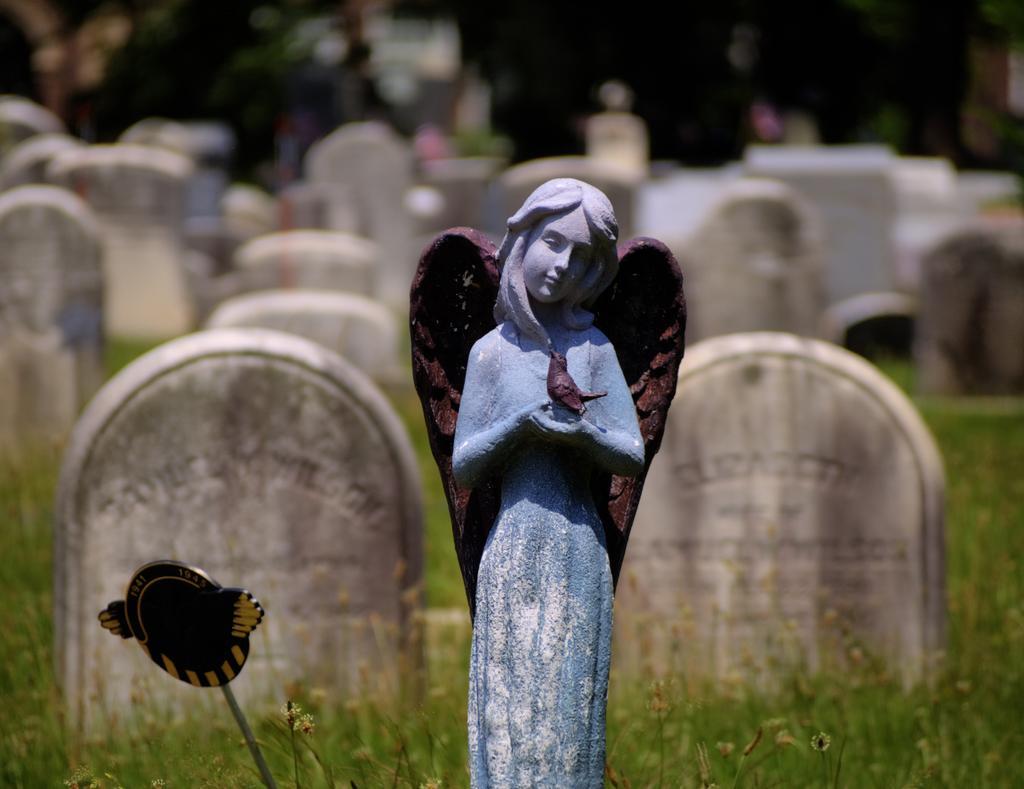Can you describe this image briefly? In this picture we can see a sculpture of woman and there is a bird on her hands. On the background We can see many stones. This is the grass. 